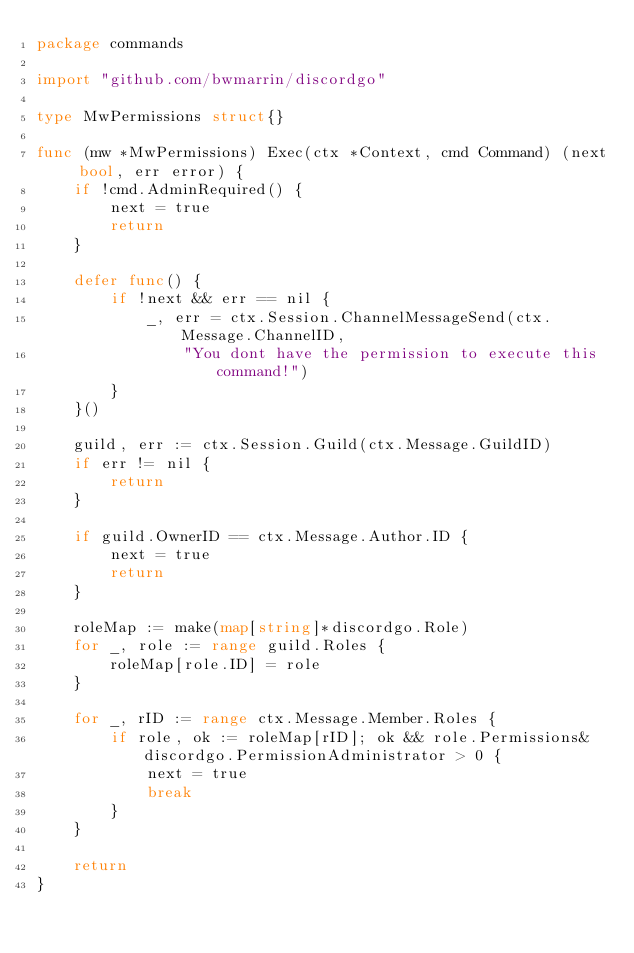Convert code to text. <code><loc_0><loc_0><loc_500><loc_500><_Go_>package commands

import "github.com/bwmarrin/discordgo"

type MwPermissions struct{}

func (mw *MwPermissions) Exec(ctx *Context, cmd Command) (next bool, err error) {
	if !cmd.AdminRequired() {
		next = true
		return
	}

	defer func() {
		if !next && err == nil {
			_, err = ctx.Session.ChannelMessageSend(ctx.Message.ChannelID,
				"You dont have the permission to execute this command!")
		}
	}()

	guild, err := ctx.Session.Guild(ctx.Message.GuildID)
	if err != nil {
		return
	}

	if guild.OwnerID == ctx.Message.Author.ID {
		next = true
		return
	}

	roleMap := make(map[string]*discordgo.Role)
	for _, role := range guild.Roles {
		roleMap[role.ID] = role
	}

	for _, rID := range ctx.Message.Member.Roles {
		if role, ok := roleMap[rID]; ok && role.Permissions&discordgo.PermissionAdministrator > 0 {
			next = true
			break
		}
	}

	return
}
</code> 